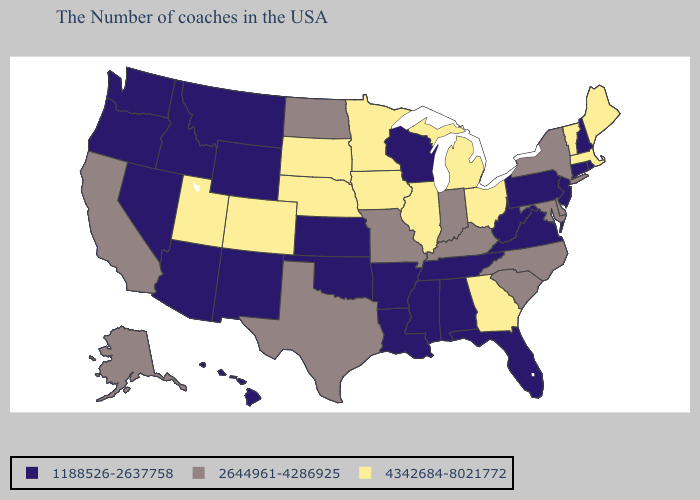What is the highest value in the South ?
Quick response, please. 4342684-8021772. Name the states that have a value in the range 4342684-8021772?
Concise answer only. Maine, Massachusetts, Vermont, Ohio, Georgia, Michigan, Illinois, Minnesota, Iowa, Nebraska, South Dakota, Colorado, Utah. Does Delaware have the same value as Maryland?
Give a very brief answer. Yes. What is the highest value in the Northeast ?
Short answer required. 4342684-8021772. What is the value of Alabama?
Quick response, please. 1188526-2637758. What is the value of Utah?
Answer briefly. 4342684-8021772. Does Pennsylvania have the lowest value in the USA?
Be succinct. Yes. What is the highest value in the South ?
Give a very brief answer. 4342684-8021772. Does Delaware have the lowest value in the South?
Keep it brief. No. Name the states that have a value in the range 1188526-2637758?
Write a very short answer. Rhode Island, New Hampshire, Connecticut, New Jersey, Pennsylvania, Virginia, West Virginia, Florida, Alabama, Tennessee, Wisconsin, Mississippi, Louisiana, Arkansas, Kansas, Oklahoma, Wyoming, New Mexico, Montana, Arizona, Idaho, Nevada, Washington, Oregon, Hawaii. Does Kentucky have the same value as Indiana?
Give a very brief answer. Yes. What is the value of South Carolina?
Keep it brief. 2644961-4286925. Does Indiana have the same value as Tennessee?
Answer briefly. No. Among the states that border Massachusetts , which have the lowest value?
Give a very brief answer. Rhode Island, New Hampshire, Connecticut. Does the first symbol in the legend represent the smallest category?
Give a very brief answer. Yes. 